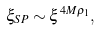<formula> <loc_0><loc_0><loc_500><loc_500>\xi _ { S P } \sim \xi ^ { 4 M \varrho _ { 1 } } ,</formula> 